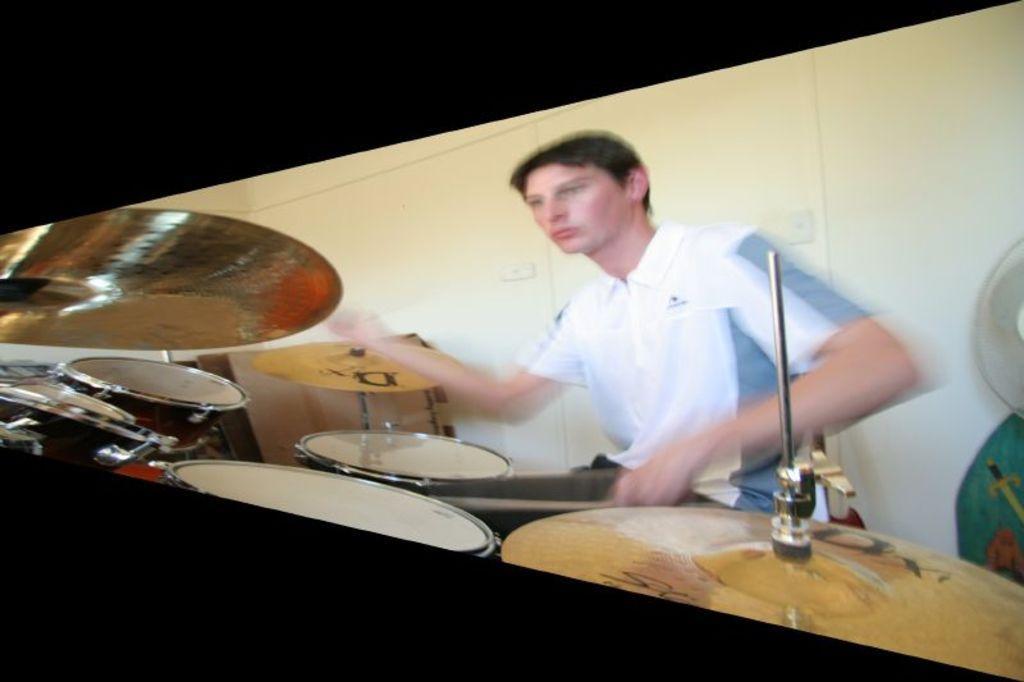In one or two sentences, can you explain what this image depicts? In this image we can see a person is playing drums and he is wearing white color t-shirt. 